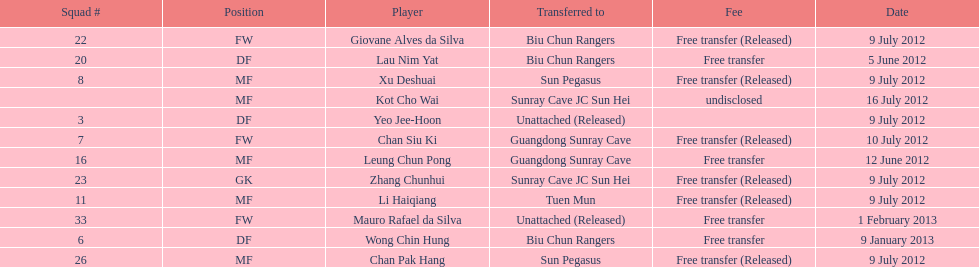Wong chin hung was transferred to his new team on what date? 9 January 2013. 